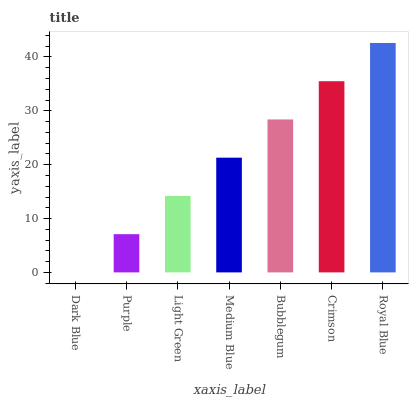Is Dark Blue the minimum?
Answer yes or no. Yes. Is Royal Blue the maximum?
Answer yes or no. Yes. Is Purple the minimum?
Answer yes or no. No. Is Purple the maximum?
Answer yes or no. No. Is Purple greater than Dark Blue?
Answer yes or no. Yes. Is Dark Blue less than Purple?
Answer yes or no. Yes. Is Dark Blue greater than Purple?
Answer yes or no. No. Is Purple less than Dark Blue?
Answer yes or no. No. Is Medium Blue the high median?
Answer yes or no. Yes. Is Medium Blue the low median?
Answer yes or no. Yes. Is Bubblegum the high median?
Answer yes or no. No. Is Purple the low median?
Answer yes or no. No. 